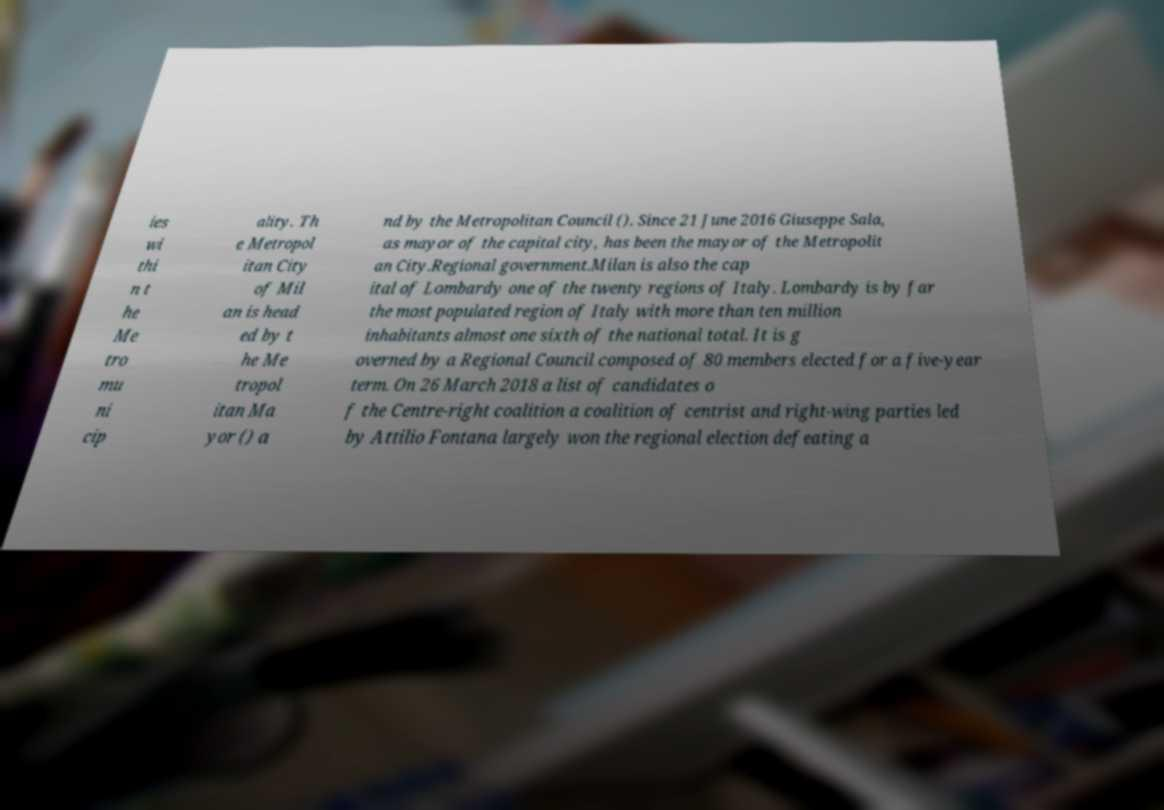For documentation purposes, I need the text within this image transcribed. Could you provide that? ies wi thi n t he Me tro mu ni cip ality. Th e Metropol itan City of Mil an is head ed by t he Me tropol itan Ma yor () a nd by the Metropolitan Council (). Since 21 June 2016 Giuseppe Sala, as mayor of the capital city, has been the mayor of the Metropolit an City.Regional government.Milan is also the cap ital of Lombardy one of the twenty regions of Italy. Lombardy is by far the most populated region of Italy with more than ten million inhabitants almost one sixth of the national total. It is g overned by a Regional Council composed of 80 members elected for a five-year term. On 26 March 2018 a list of candidates o f the Centre-right coalition a coalition of centrist and right-wing parties led by Attilio Fontana largely won the regional election defeating a 